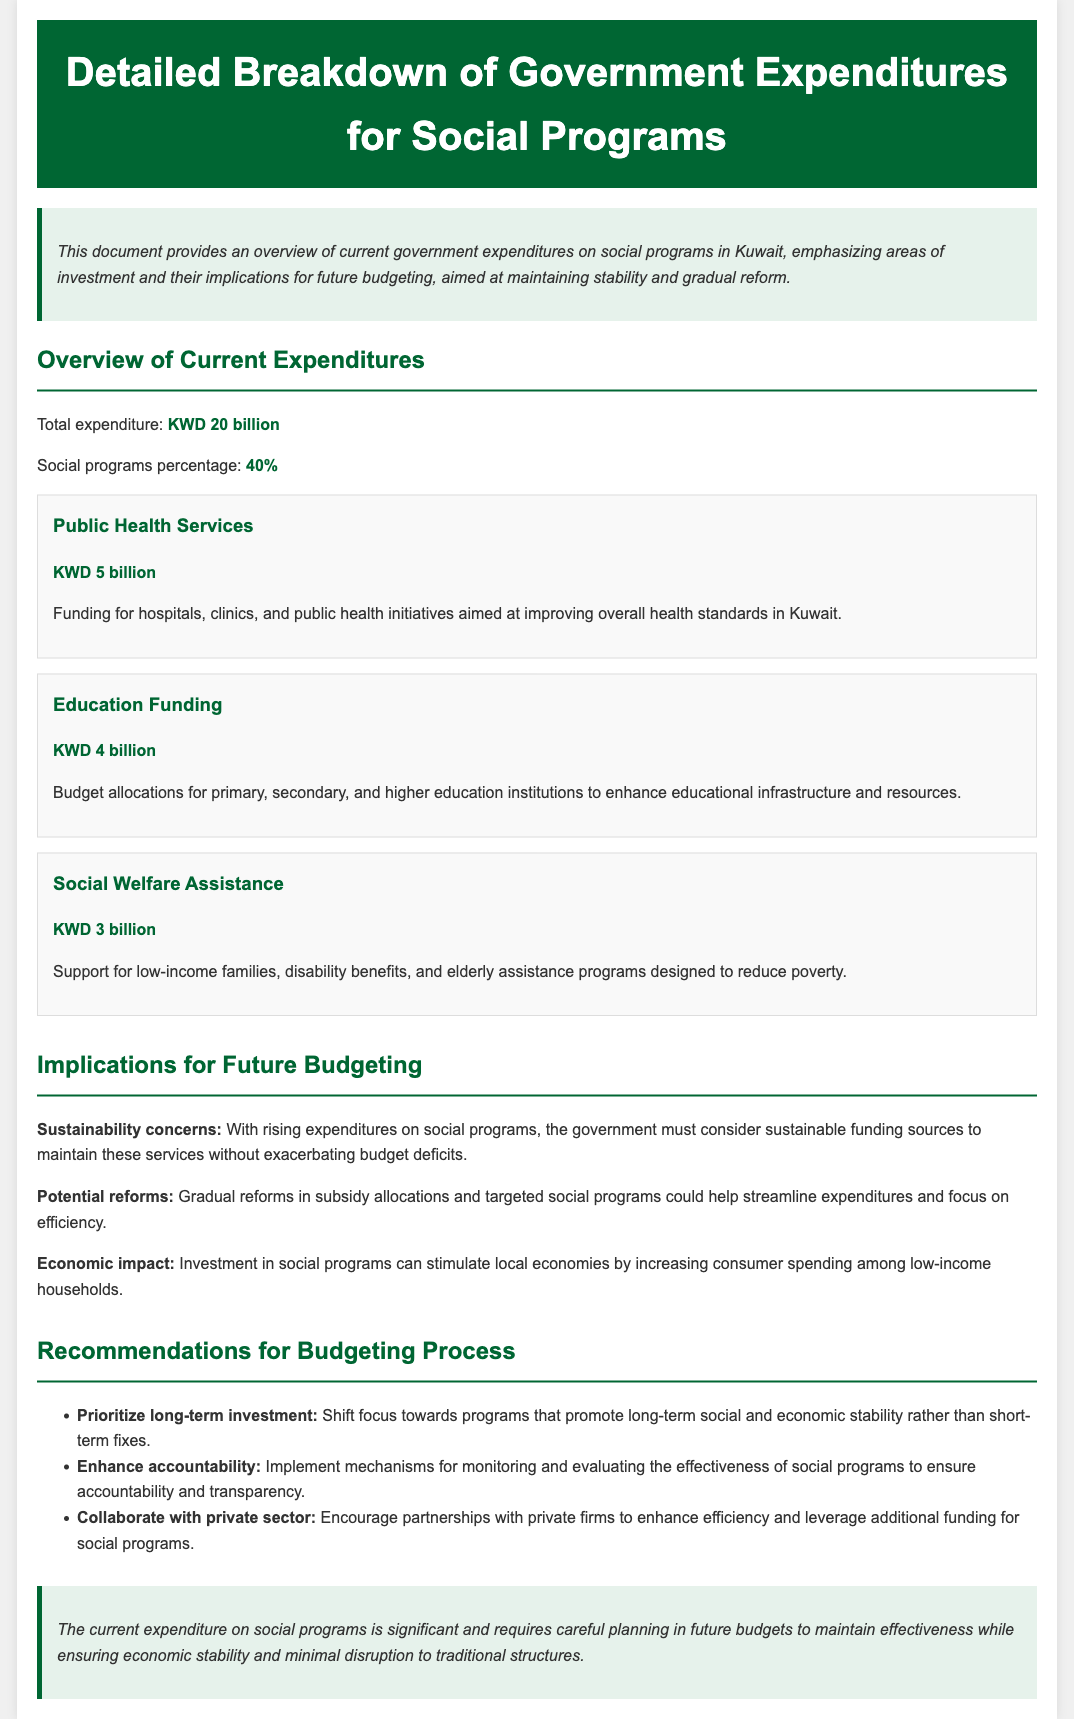What is the total expenditure? The total expenditure mentioned in the document is for all government expenses, stated directly in the overview section.
Answer: KWD 20 billion What percentage of expenditures is allocated to social programs? This percentage is specified in the overview section and reflects how much of the budget goes to social initiatives.
Answer: 40% How much is allocated for Public Health Services? This amount is detailed in the section regarding specific programs and is meant for healthcare improvements.
Answer: KWD 5 billion What is the funding amount for Education? This value can be found in the breakdown of expenditures for educational institutions in the document.
Answer: KWD 4 billion What is the expenditure for Social Welfare Assistance? This figure indicates the support allocated for various welfare initiatives according to the document's specifics.
Answer: KWD 3 billion What is a sustainability concern mentioned for future budgeting? This concern reflects the implications of rising expenditures on the ability of the government to maintain social service funding without negative consequences.
Answer: Budget deficits What should be prioritized according to the recommendations? This recommendation emphasizes a strategic approach to expenditures rather than reactive measures, as stated in the recommendations section.
Answer: Long-term investment How can accountability be enhanced in social programs? The document suggests a method to improve oversight and ensure responsible use of funds through specific measures described.
Answer: Monitoring and evaluating effectiveness What is one implication of investing in social programs? This implication discusses the broader economic effects related to expenditures on social welfare, highlighting its importance in economic terms.
Answer: Stimulate local economies 